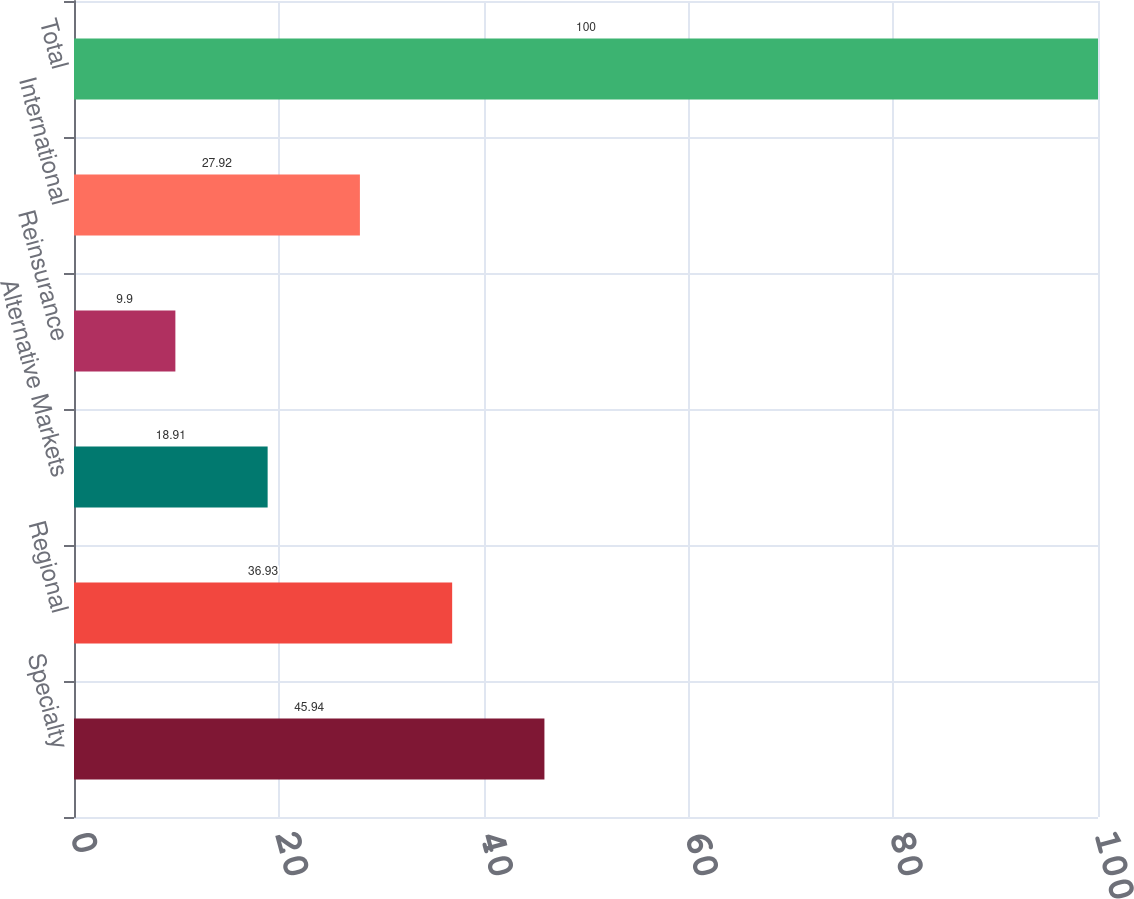Convert chart. <chart><loc_0><loc_0><loc_500><loc_500><bar_chart><fcel>Specialty<fcel>Regional<fcel>Alternative Markets<fcel>Reinsurance<fcel>International<fcel>Total<nl><fcel>45.94<fcel>36.93<fcel>18.91<fcel>9.9<fcel>27.92<fcel>100<nl></chart> 